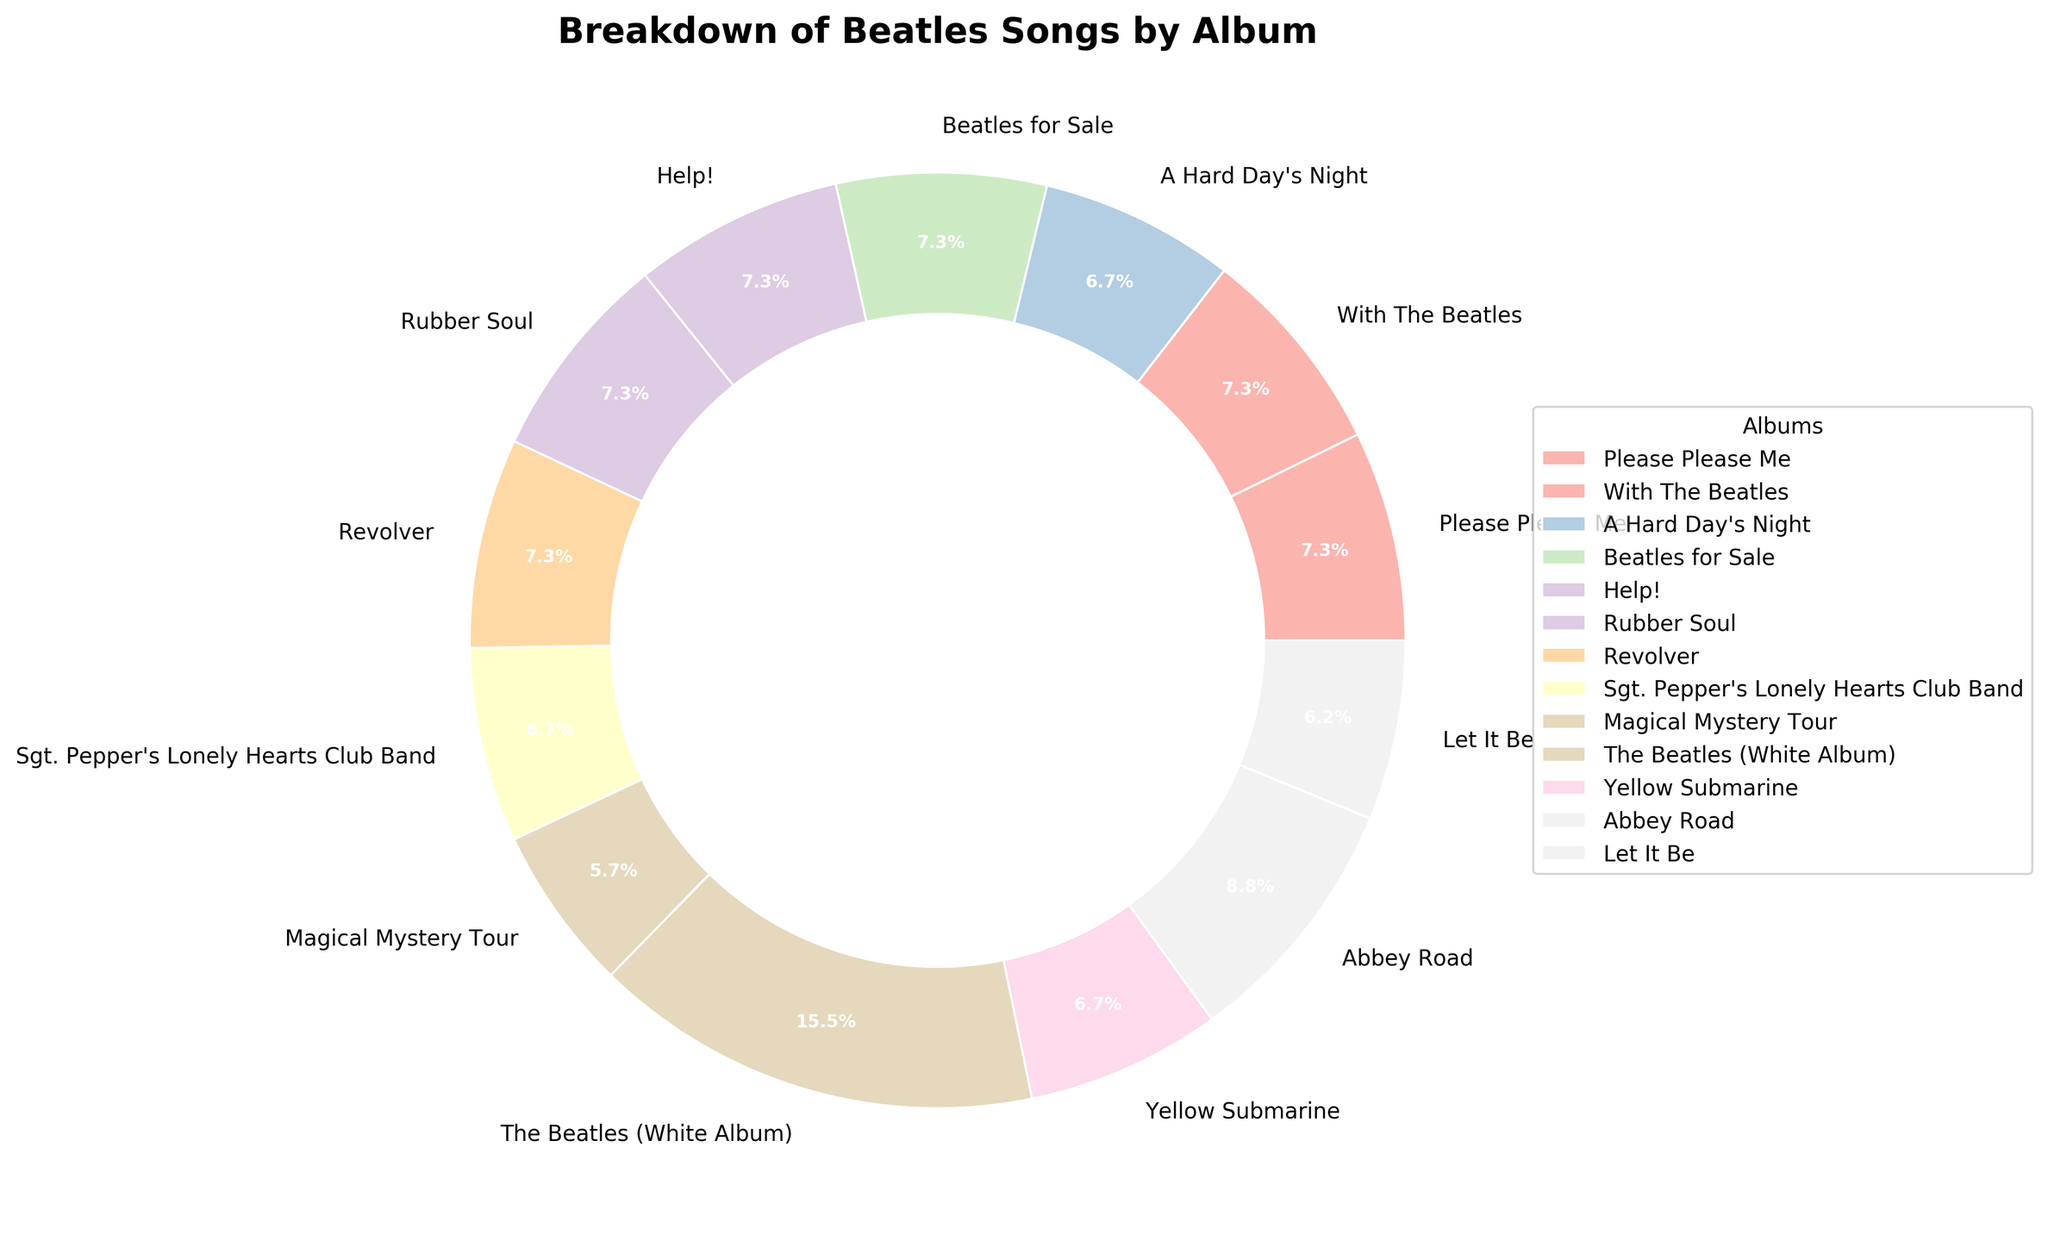Which album has the largest number of songs? By visual inspection of the pie chart and the labeled slices, the album with the widest segment represents the largest number of songs. "The Beatles (White Album)" has the largest segment.
Answer: The Beatles (White Album) What percentage of songs does the "Abbey Road" album contribute? Look for the "Abbey Road" segment in the pie chart, which is labeled with both the album name and the percentage. The label for "Abbey Road" shows 9.9%.
Answer: 9.9% How many more songs are in "The Beatles (White Album)" than in "Let It Be"? Identify the number of songs in both albums: "The Beatles (White Album)" has 30 songs, and "Let It Be" has 12. Subtract the smaller number from the larger number: 30 - 12 = 18.
Answer: 18 Which albums have an equal number of songs? Check the labels on the pie chart to find albums with the same number of songs. "Please Please Me," "With The Beatles," "Beatles for Sale," "Help!," "Rubber Soul," and "Revolver" each have 14 songs.
Answer: Please Please Me, With The Beatles, Beatles for Sale, Help!, Rubber Soul, Revolver What is the combined percentage of songs from "Sgt. Pepper’s Lonely Hearts Club Band" and "Magical Mystery Tour"? Identify the percentages labeled on the pie chart for both albums. "Sgt. Pepper’s Lonely Hearts Club Band" has 9.2%, and "Magical Mystery Tour" has 7.8%. Add these percentages: 9.2 + 7.8 = 17%.
Answer: 17% Is the number of songs in "Abbey Road" greater than the combined number of songs in "A Hard Day's Night" and "Yellow Submarine"? Compare the number of songs: "Abbey Road" has 17 songs. "A Hard Day's Night" has 13 and "Yellow Submarine" has 13. Sum the songs from the latter two: 13 + 13 = 26. Since 17 is less than 26, the answer is no.
Answer: No What is the visual indication of the album segment with the fewest songs? The smallest segment in the pie chart represents the album with the fewest songs. This segment is labeled "Magical Mystery Tour."
Answer: Magical Mystery Tour If you were to group albums with more than 15 songs together, which albums would that be? Look for the segments labeled with more than 15 songs: "Abbey Road" (17 songs) and "The Beatles (White Album)" (30 songs).
Answer: Abbey Road, The Beatles (White Album) Which album has the second largest number of songs after "The Beatles (White Album)"? First, recognize that "The Beatles (White Album)" has the largest segment with 30 songs. Next, find the second largest segment, which is labeled "Abbey Road" with 17 songs.
Answer: Abbey Road 